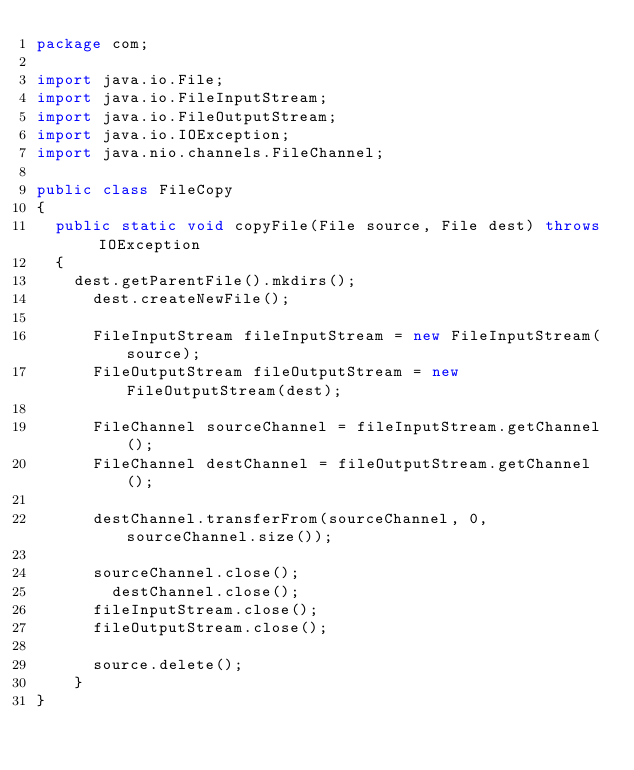<code> <loc_0><loc_0><loc_500><loc_500><_Java_>package com;

import java.io.File;
import java.io.FileInputStream;
import java.io.FileOutputStream;
import java.io.IOException;
import java.nio.channels.FileChannel;

public class FileCopy 
{
	public static void copyFile(File source, File dest) throws IOException 
	{
		dest.getParentFile().mkdirs(); 
	    dest.createNewFile();
	    
	    FileInputStream fileInputStream = new FileInputStream(source);
	    FileOutputStream fileOutputStream = new FileOutputStream(dest);
	    
	    FileChannel sourceChannel = fileInputStream.getChannel();
	    FileChannel destChannel = fileOutputStream.getChannel();
        
	    destChannel.transferFrom(sourceChannel, 0, sourceChannel.size());
        
	    sourceChannel.close();
        destChannel.close();
    	fileInputStream.close();
    	fileOutputStream.close();
        
    	source.delete();
    }
}
</code> 